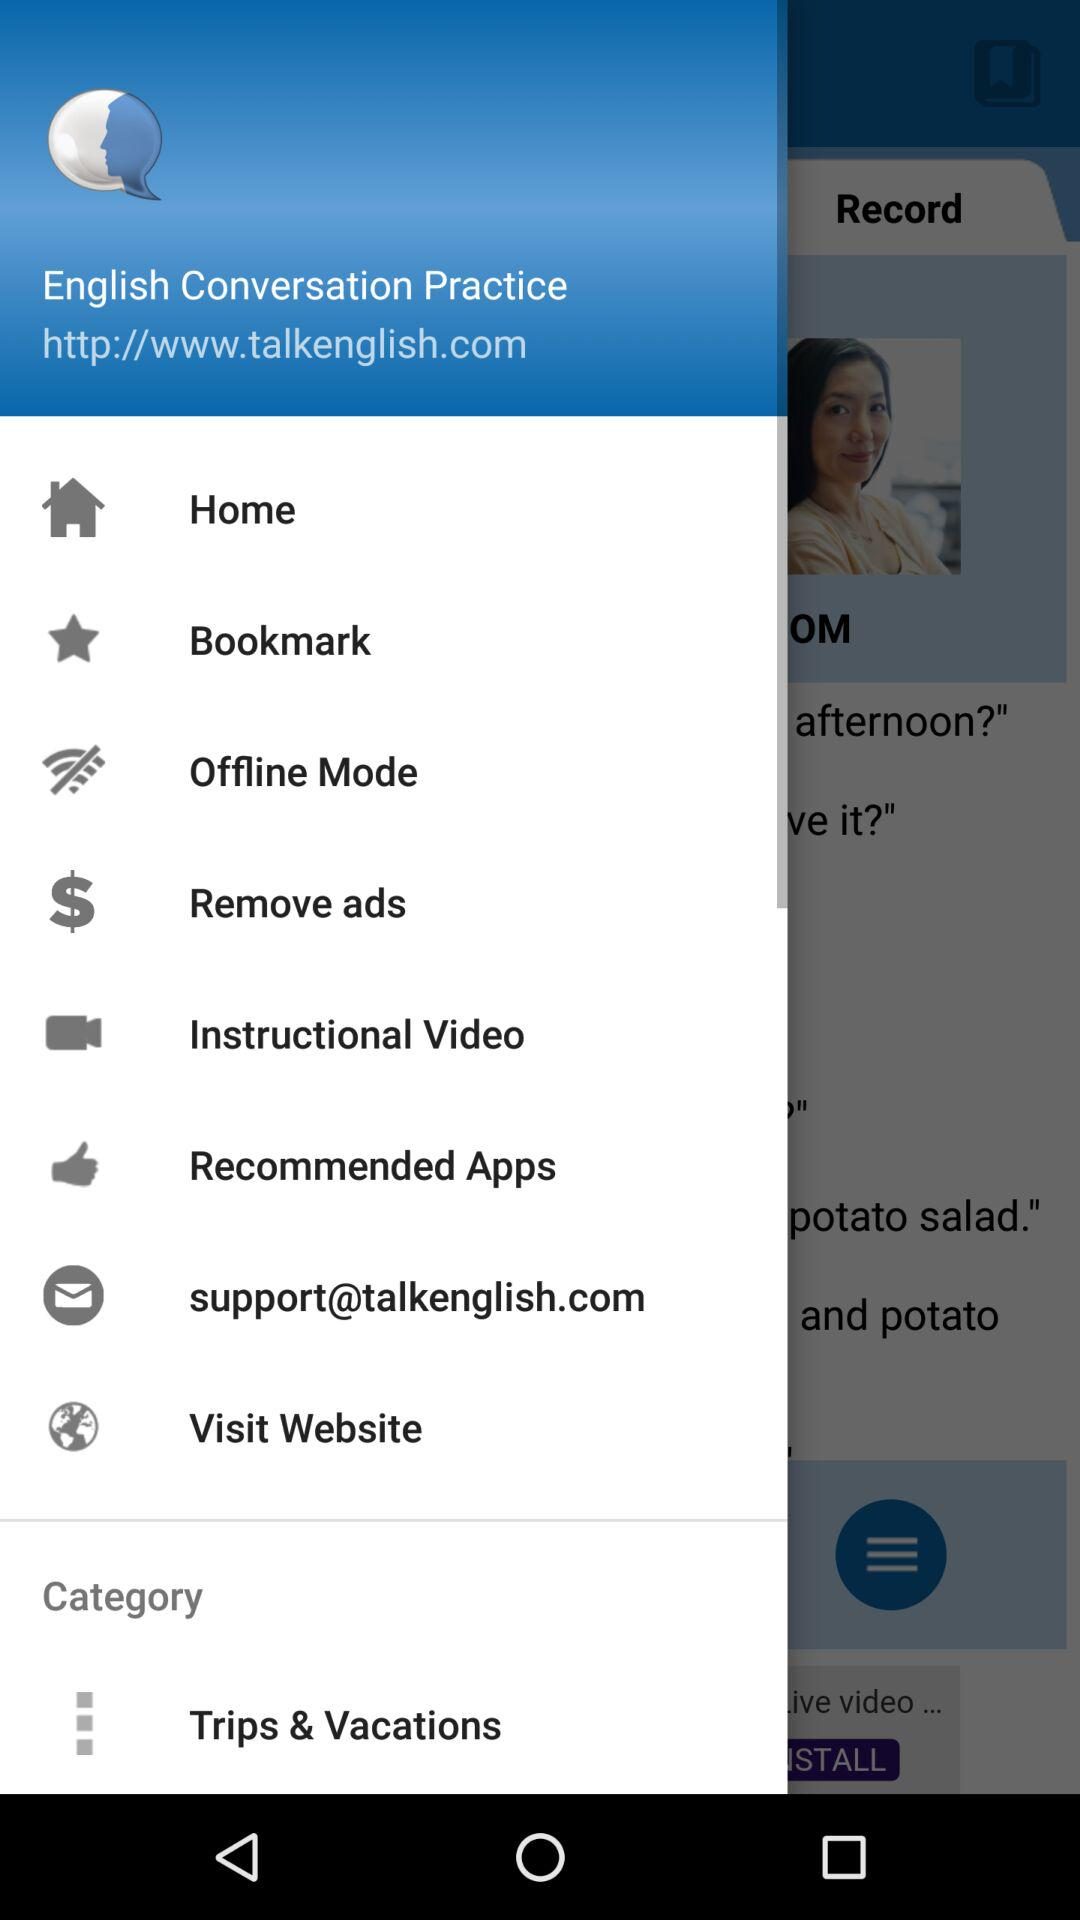What's the URL? The URL is http://www.talkenglish.com. 